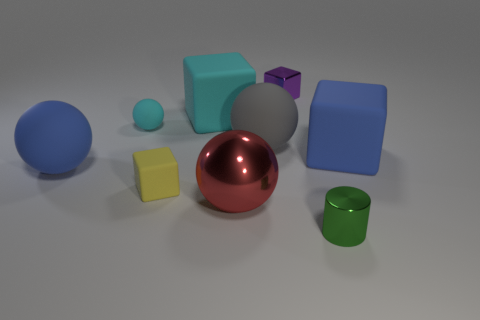There is a cube that is the same color as the small matte sphere; what is its material?
Provide a succinct answer. Rubber. Does the big blue sphere have the same material as the blue block?
Offer a very short reply. Yes. How many cyan rubber cubes are to the right of the block on the right side of the small shiny object that is on the left side of the metal cylinder?
Offer a very short reply. 0. Are there any large things that have the same material as the cyan sphere?
Offer a very short reply. Yes. Is the number of brown metal things less than the number of big blue things?
Give a very brief answer. Yes. Do the big rubber block that is on the left side of the small cylinder and the tiny ball have the same color?
Your answer should be compact. Yes. What is the ball that is in front of the big blue thing in front of the blue thing on the right side of the yellow thing made of?
Provide a succinct answer. Metal. Is there a rubber object that has the same color as the tiny sphere?
Keep it short and to the point. Yes. Are there fewer small metal cylinders that are behind the small green object than tiny purple cylinders?
Keep it short and to the point. No. There is a cyan thing that is left of the yellow thing; is it the same size as the tiny yellow rubber block?
Provide a short and direct response. Yes. 